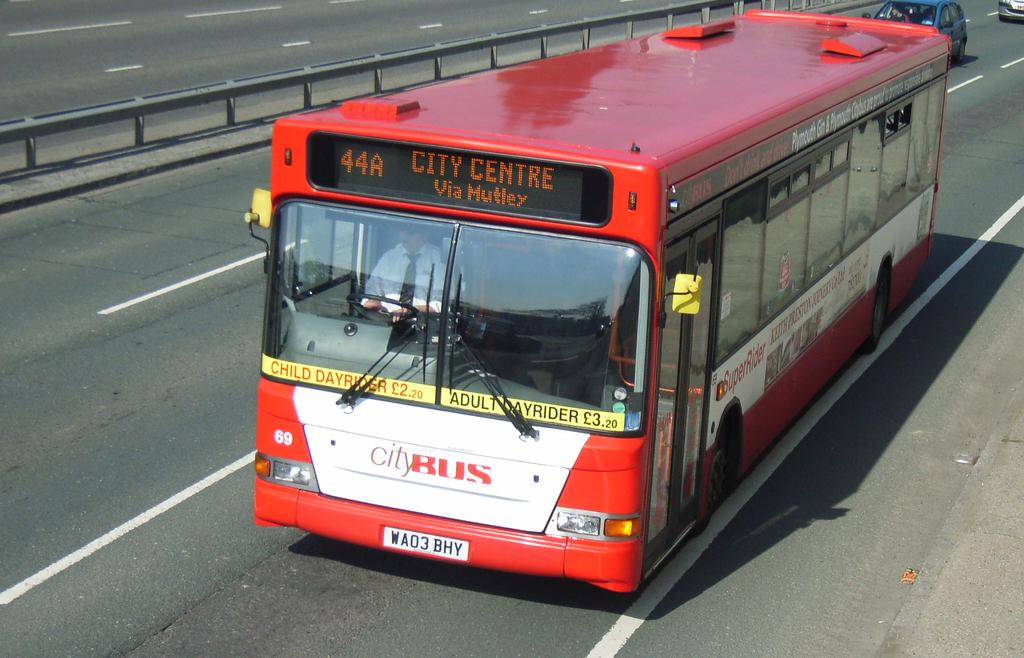What type of vehicle is the main subject in the image? There is a bus on the road in the image. Can you describe the surroundings of the bus? There are other vehicles visible in the background. Is there anyone inside the bus? Yes, there is a person inside the bus. What can be seen on the exterior of the bus? There is text on the bus. What kind of structure is present in the image? There is a railing in the image. What type of fruit is being served with a fork on the top of the bus in the image? There is no fruit or fork present on the bus in the image. 